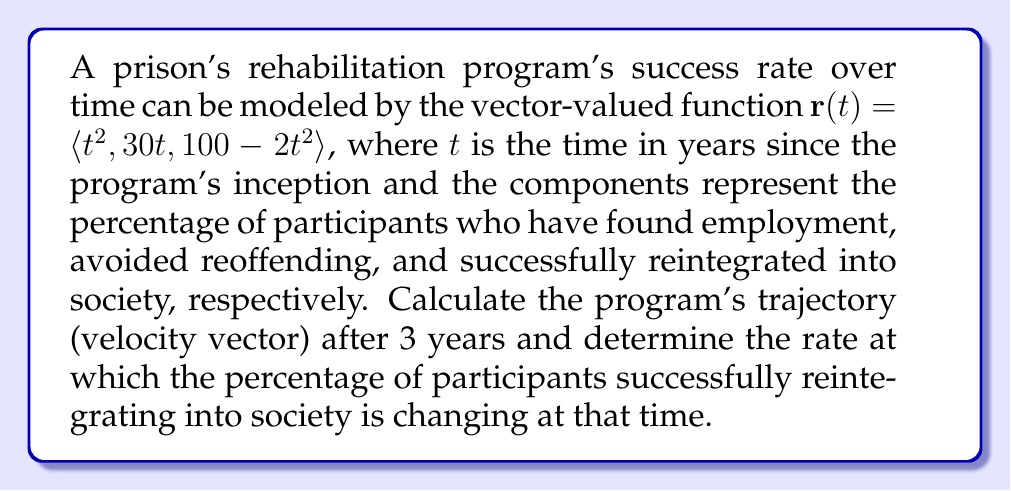Can you solve this math problem? To solve this problem, we need to follow these steps:

1) The trajectory (velocity vector) of the rehabilitation program's success rate is given by the derivative of the position vector $\mathbf{r}(t)$. We can find this by differentiating each component:

   $\mathbf{r}'(t) = \langle \frac{d}{dt}(t^2), \frac{d}{dt}(30t), \frac{d}{dt}(100-2t^2) \rangle$
   
   $\mathbf{r}'(t) = \langle 2t, 30, -4t \rangle$

2) To find the trajectory after 3 years, we evaluate $\mathbf{r}'(t)$ at $t=3$:

   $\mathbf{r}'(3) = \langle 2(3), 30, -4(3) \rangle = \langle 6, 30, -12 \rangle$

3) The rate at which the percentage of participants successfully reintegrating into society is changing is represented by the third component of the velocity vector. At $t=3$, this rate is $-12$ percent per year.
Answer: The trajectory (velocity vector) after 3 years is $\langle 6, 30, -12 \rangle$, and the rate at which the percentage of participants successfully reintegrating into society is changing at that time is $-12$ percent per year. 